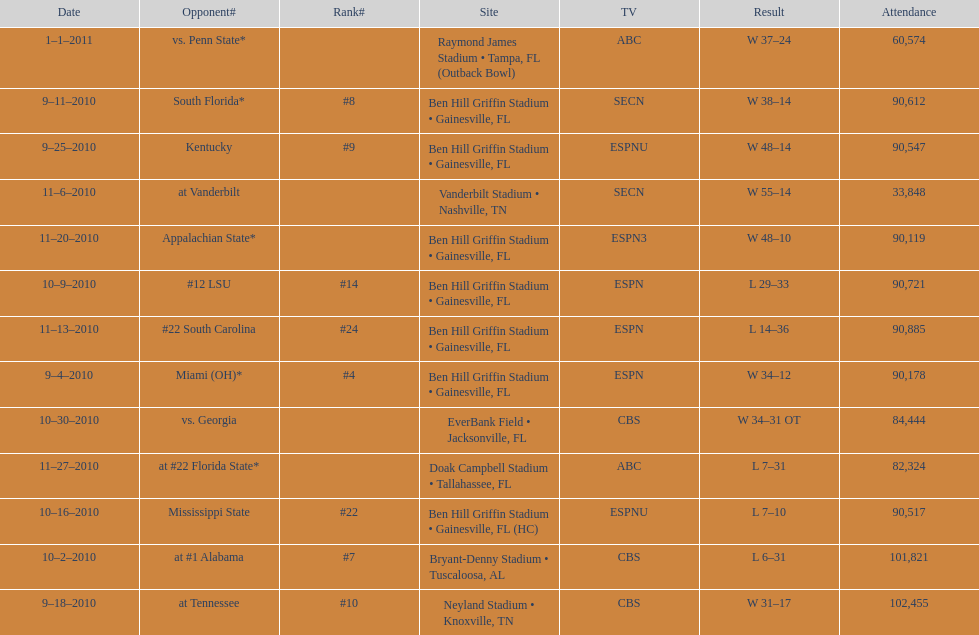What tv network showed the largest number of games during the 2010/2011 season? ESPN. 